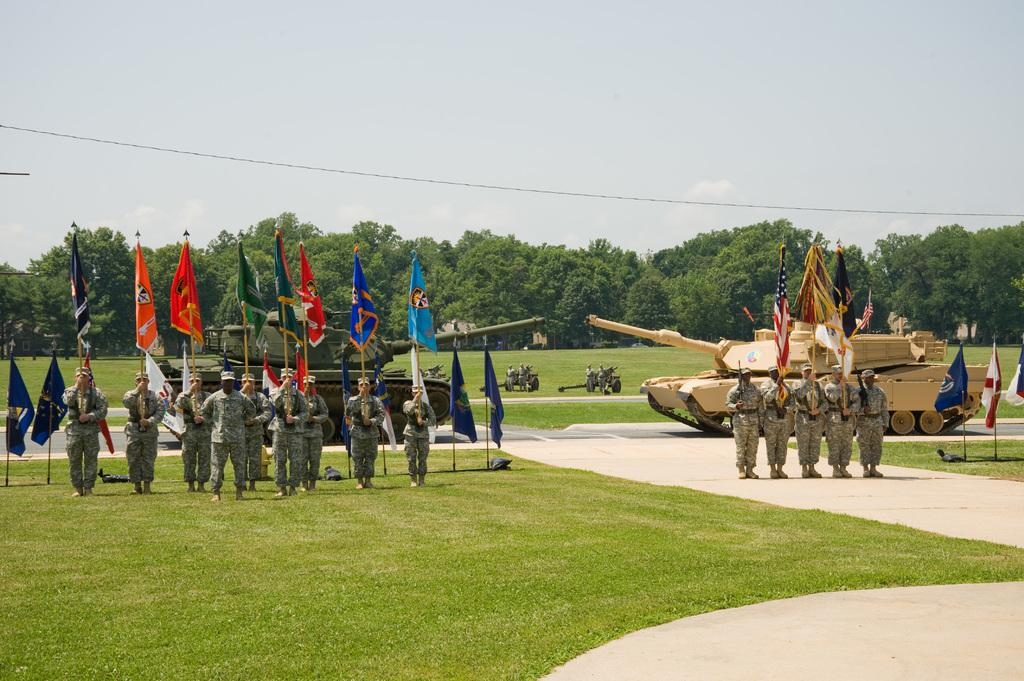What can be seen in the image? There are soldiers in the image. What are the soldiers holding in their hands? The soldiers are holding flags in their hands. Where are the soldiers standing? The soldiers are standing on a ground. What can be seen in the background of the image? There are two machines and trees in the background of the image, as well as the sky. What color is the crayon being used by the soldiers in the image? There is no crayon present in the image; the soldiers are holding flags. How do the soldiers control the machines in the background of the image? The soldiers are not controlling any machines in the image; they are holding flags and standing on the ground. 